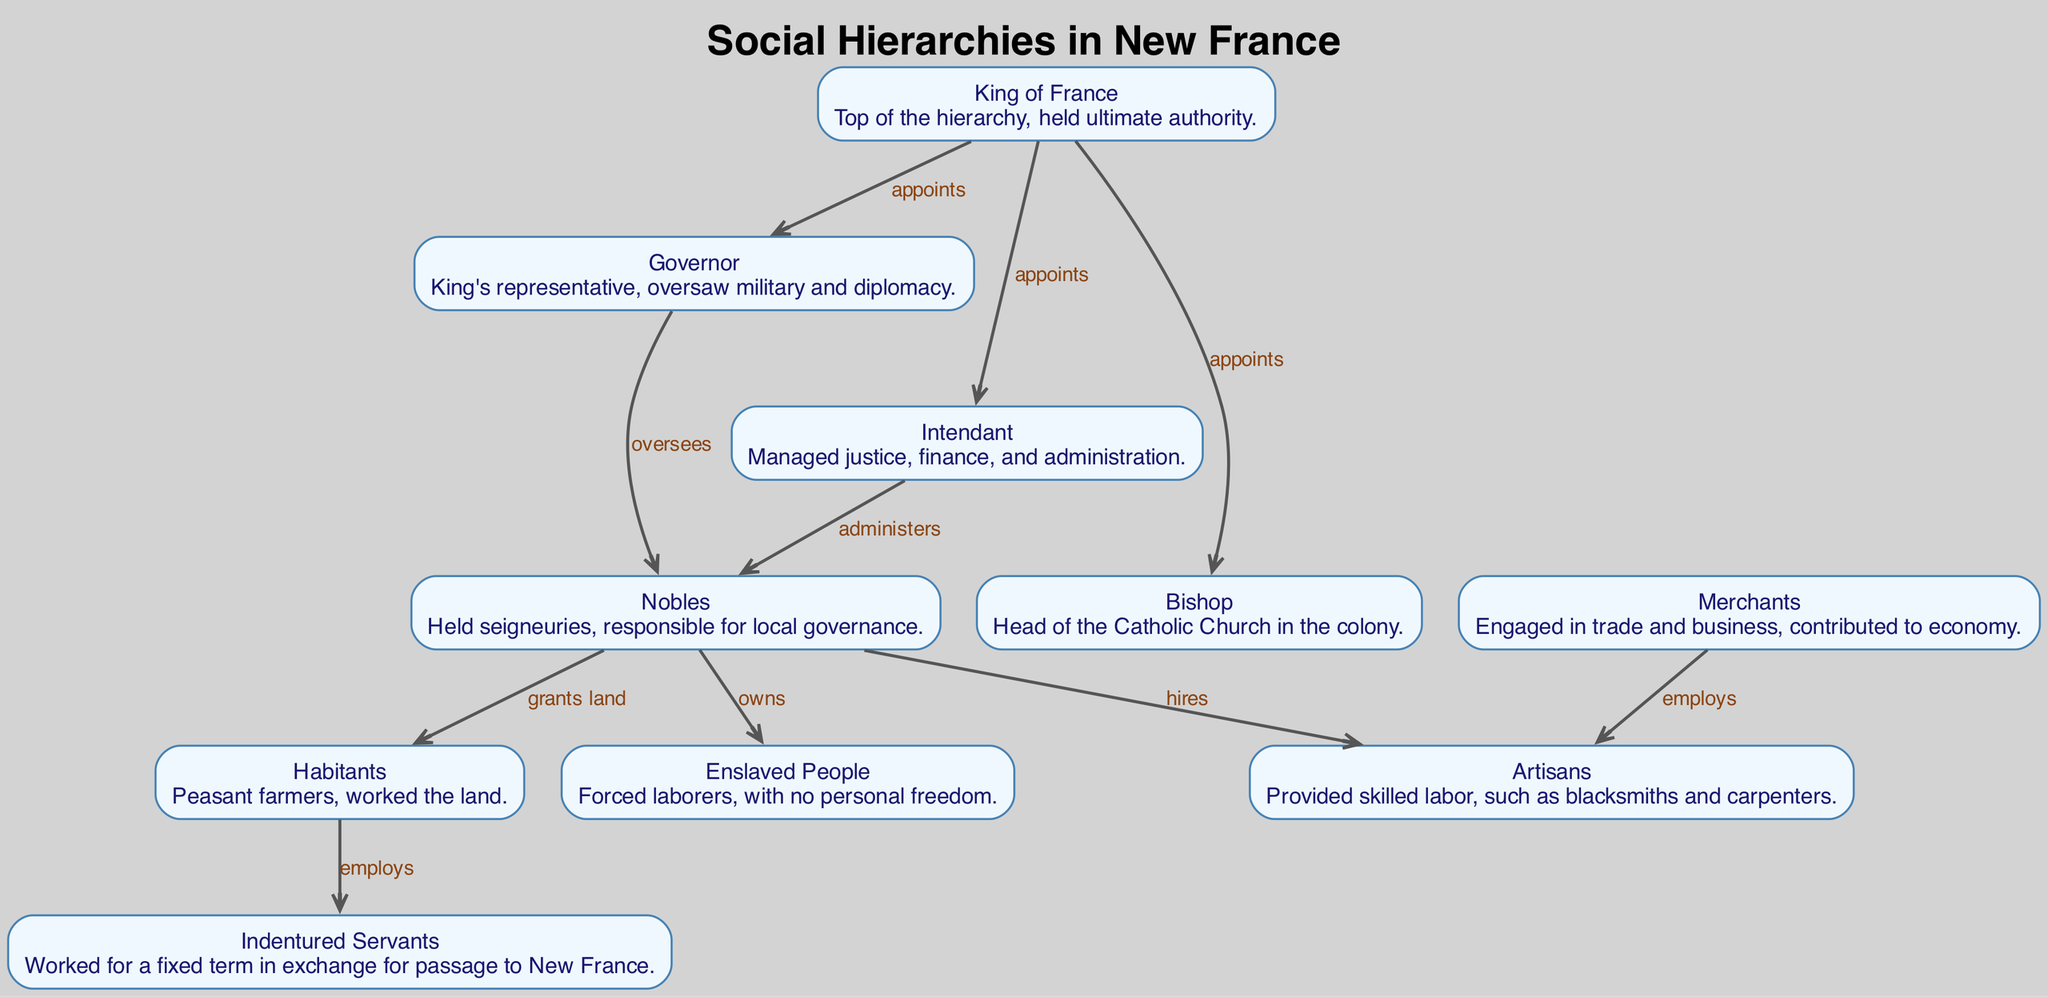What is the top rank in the social hierarchy of New France? The diagram clearly indicates that the "King of France" is at the top of the hierarchy, as he is noted to hold ultimate authority over all other ranks.
Answer: King of France How many roles are higher than the "Bishop" in the hierarchy? In the diagram, there are three roles above the Bishop: the King of France, the Governor, and the Intendant. Counting these gives us a total of three.
Answer: 3 Who appoints the "Intendant"? The diagram shows a direct edge from the "King of France" to the "Intendant" with the relation labeled as "appoints", indicating that the King appoints the Intendant.
Answer: King of France Which group employs "Artisans"? The diagram illustrates that "Merchants" employ "Artisans", showing the relationship clearly with a directed edge labeled "employs" from Merchants to Artisans.
Answer: Merchants What relation do "Nobles" have with "Habitants"? In the diagram, there is an edge labeled "grants land" from "Nobles" to "Habitants", which indicates that Nobles grant land to Habitants.
Answer: grants land How many edges are directed towards "Habitants"? Upon examining the diagram, it can be seen that the "Habitants" receive directed edges from "Nobles" (grants land) and employ "Indentured Servants". This provides a total of two edges directed towards Habitants.
Answer: 2 What role comes directly after "Governor" in the hierarchy? The diagram does not show a direct successor to the Governor but reveals the Governor oversees the "Nobles", which indicates Nobles are the next significant rank under the Governor's authority.
Answer: Nobles Who oversees the "Nobles"? The diagram indicates that both the "Governor" and the "Intendant" hold overseeing roles over the "Nobles". Notably, there are directed edges from both roles to the Nobles.
Answer: Governor and Intendant Which group is directly connected to "Enslaved People"? The diagram shows a direct connection from "Nobles" to "Enslaved People", with the relationship labeled as "owns", indicating that Nobles own Enslaved People.
Answer: Nobles 